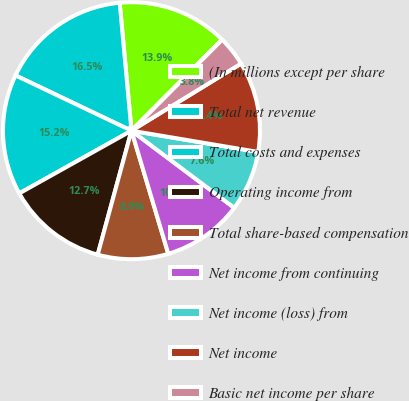<chart> <loc_0><loc_0><loc_500><loc_500><pie_chart><fcel>(In millions except per share<fcel>Total net revenue<fcel>Total costs and expenses<fcel>Operating income from<fcel>Total share-based compensation<fcel>Net income from continuing<fcel>Net income (loss) from<fcel>Net income<fcel>Basic net income per share<fcel>Basic net income (loss) per<nl><fcel>13.92%<fcel>16.46%<fcel>15.19%<fcel>12.66%<fcel>8.86%<fcel>10.13%<fcel>7.6%<fcel>11.39%<fcel>3.8%<fcel>0.0%<nl></chart> 